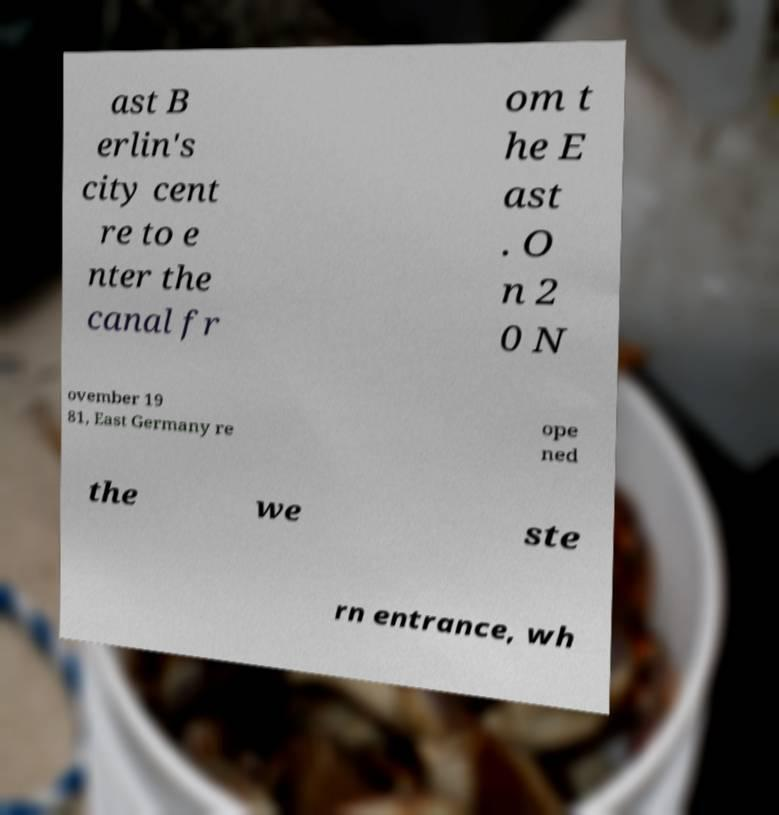Can you read and provide the text displayed in the image?This photo seems to have some interesting text. Can you extract and type it out for me? ast B erlin's city cent re to e nter the canal fr om t he E ast . O n 2 0 N ovember 19 81, East Germany re ope ned the we ste rn entrance, wh 